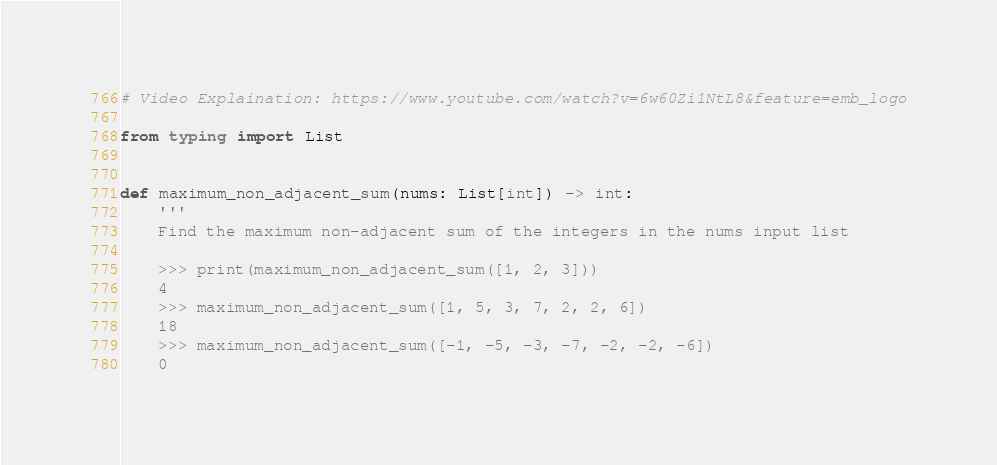Convert code to text. <code><loc_0><loc_0><loc_500><loc_500><_Python_># Video Explaination: https://www.youtube.com/watch?v=6w60Zi1NtL8&feature=emb_logo

from typing import List


def maximum_non_adjacent_sum(nums: List[int]) -> int:
    '''
    Find the maximum non-adjacent sum of the integers in the nums input list

    >>> print(maximum_non_adjacent_sum([1, 2, 3]))
    4
    >>> maximum_non_adjacent_sum([1, 5, 3, 7, 2, 2, 6])
    18
    >>> maximum_non_adjacent_sum([-1, -5, -3, -7, -2, -2, -6])
    0</code> 